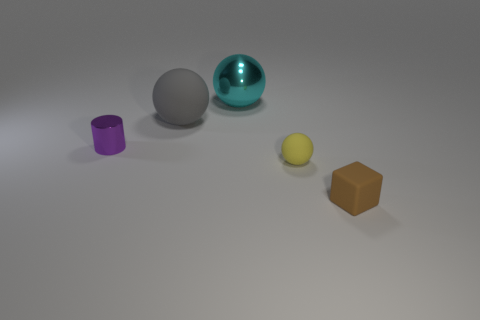Subtract all small yellow balls. How many balls are left? 2 Add 5 green shiny balls. How many objects exist? 10 Subtract all balls. How many objects are left? 2 Add 1 small things. How many small things are left? 4 Add 4 brown blocks. How many brown blocks exist? 5 Subtract 0 blue cylinders. How many objects are left? 5 Subtract all blue cylinders. Subtract all yellow rubber balls. How many objects are left? 4 